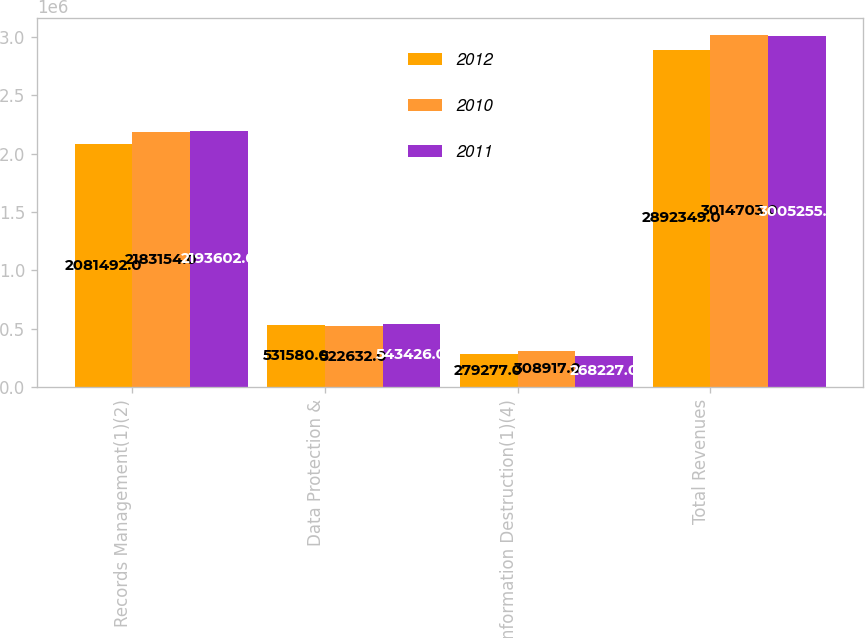Convert chart to OTSL. <chart><loc_0><loc_0><loc_500><loc_500><stacked_bar_chart><ecel><fcel>Records Management(1)(2)<fcel>Data Protection &<fcel>Information Destruction(1)(4)<fcel>Total Revenues<nl><fcel>2012<fcel>2.08149e+06<fcel>531580<fcel>279277<fcel>2.89235e+06<nl><fcel>2010<fcel>2.18315e+06<fcel>522632<fcel>308917<fcel>3.0147e+06<nl><fcel>2011<fcel>2.1936e+06<fcel>543426<fcel>268227<fcel>3.00526e+06<nl></chart> 